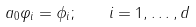Convert formula to latex. <formula><loc_0><loc_0><loc_500><loc_500>a _ { 0 } \varphi _ { i } = \phi _ { i } ; \quad i = 1 , \dots , d</formula> 